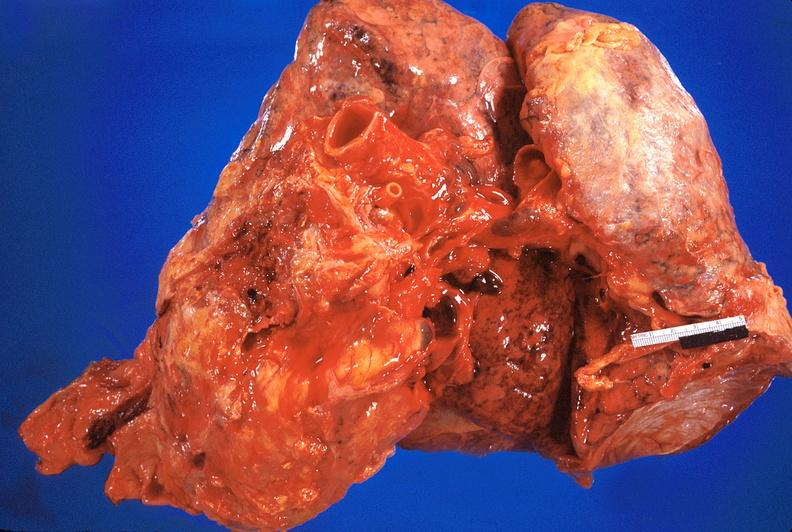s fibrinous peritonitis present?
Answer the question using a single word or phrase. No 